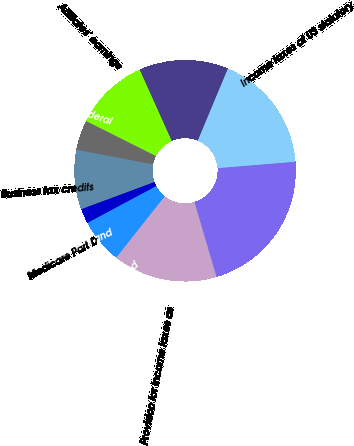Convert chart. <chart><loc_0><loc_0><loc_500><loc_500><pie_chart><fcel>(millions of dollars)<fcel>Income taxes at US statutory<fcel>Income from non-US sources<fcel>Affiliates' earnings<fcel>State taxes net of federal<fcel>Business tax credits<fcel>Accrual adjustment and<fcel>Medicare Part D<fcel>Non-temporary differences and<fcel>Provision for income taxes as<nl><fcel>21.74%<fcel>17.39%<fcel>13.04%<fcel>10.87%<fcel>4.35%<fcel>8.7%<fcel>2.17%<fcel>0.0%<fcel>6.52%<fcel>15.22%<nl></chart> 